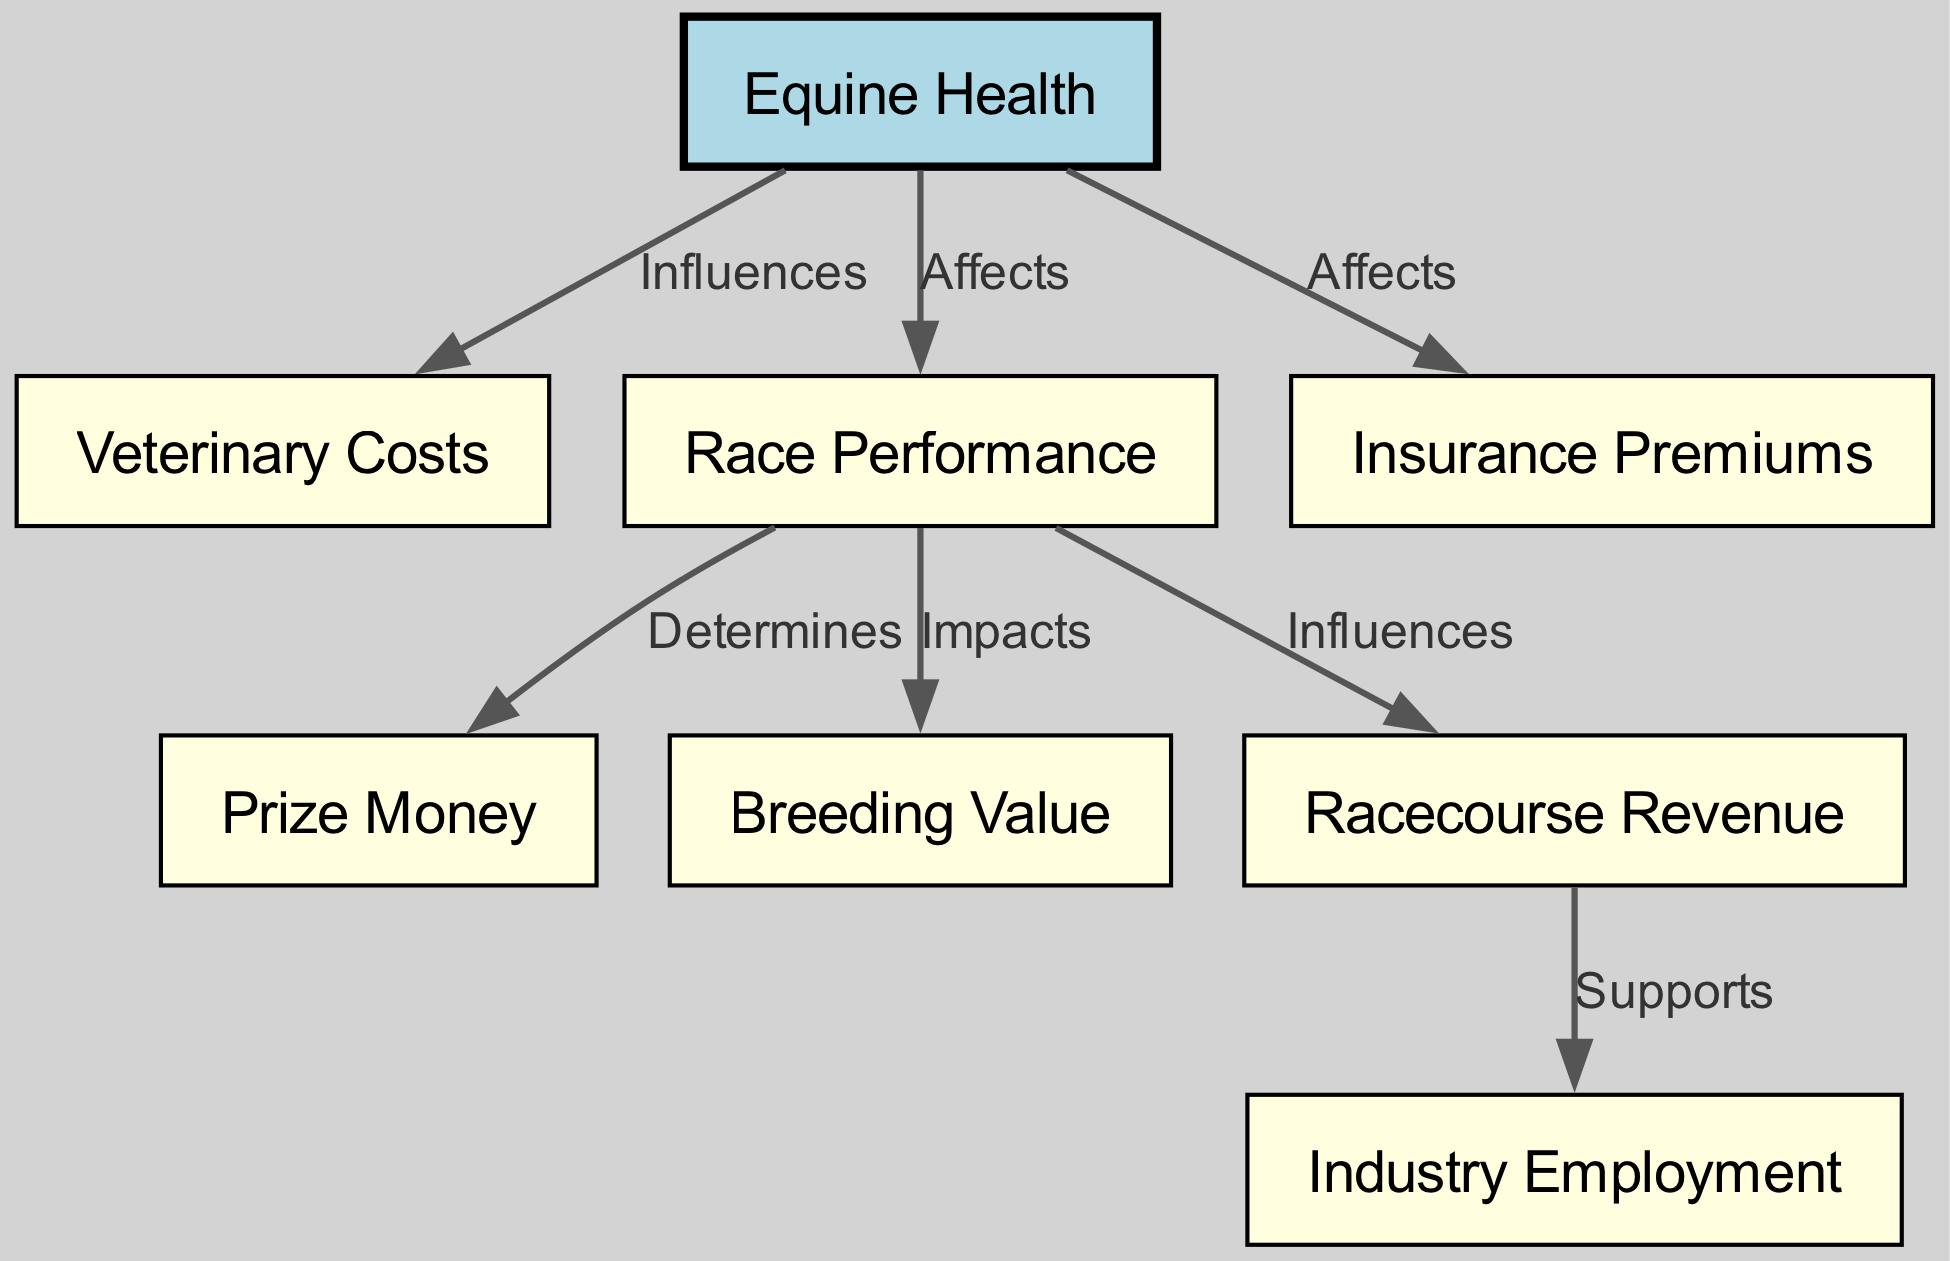What is the main node in the diagram? The main node in the diagram is labeled "Equine Health". It is the starting point from which other nodes and relationships branch out, indicating its central importance to the flowchart.
Answer: Equine Health How many nodes are present in the diagram? By counting the entries in the "nodes" array within the data, we find that there are a total of eight nodes represented.
Answer: 8 What type of relationship exists between "Equine Health" and "Veterinary Costs"? The relationship labeled "Influences" indicates that "Equine Health" affects the "Veterinary Costs", showing that the health of equines has a direct impact on the expenses incurred for veterinary services.
Answer: Influences Which node is impacted by "Race Performance"? The nodes that are impacted by "Race Performance" are "Prize Money" and "Breeding Value". The connections labeled "Determines" and "Impacts" show that race performance affects both of these aspects.
Answer: Prize Money, Breeding Value What is the effect of "Equine Health" on "Insurance Premiums"? The diagram indicates that "Equine Health" has an "Affects" relationship with "Insurance Premiums", meaning that the state of equine health directly influences the cost of insurance within the industry.
Answer: Affects How does "Racecourse Revenue" relate to "Industry Employment"? The relationship labeled "Supports" shows that "Racecourse Revenue" contributes to "Industry Employment", suggesting that increased revenue from races helps to sustain jobs in the racing industry.
Answer: Supports Which node determines "Prize Money"? The node that determines "Prize Money" is "Race Performance". The edge labeled "Determines" indicates a direct link showing that the performance of horses in races directly affects how much prize money is awarded.
Answer: Race Performance What is the connection between "Race Performance" and "Racecourse Revenue"? The connection is labeled "Influences", which indicates that the performance of horses at the races plays a crucial role in shaping the revenue that racecourses generate from events.
Answer: Influences 